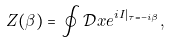Convert formula to latex. <formula><loc_0><loc_0><loc_500><loc_500>Z ( \beta ) = \oint \mathcal { D } x e ^ { i I | _ { \tau = - i \beta } } ,</formula> 